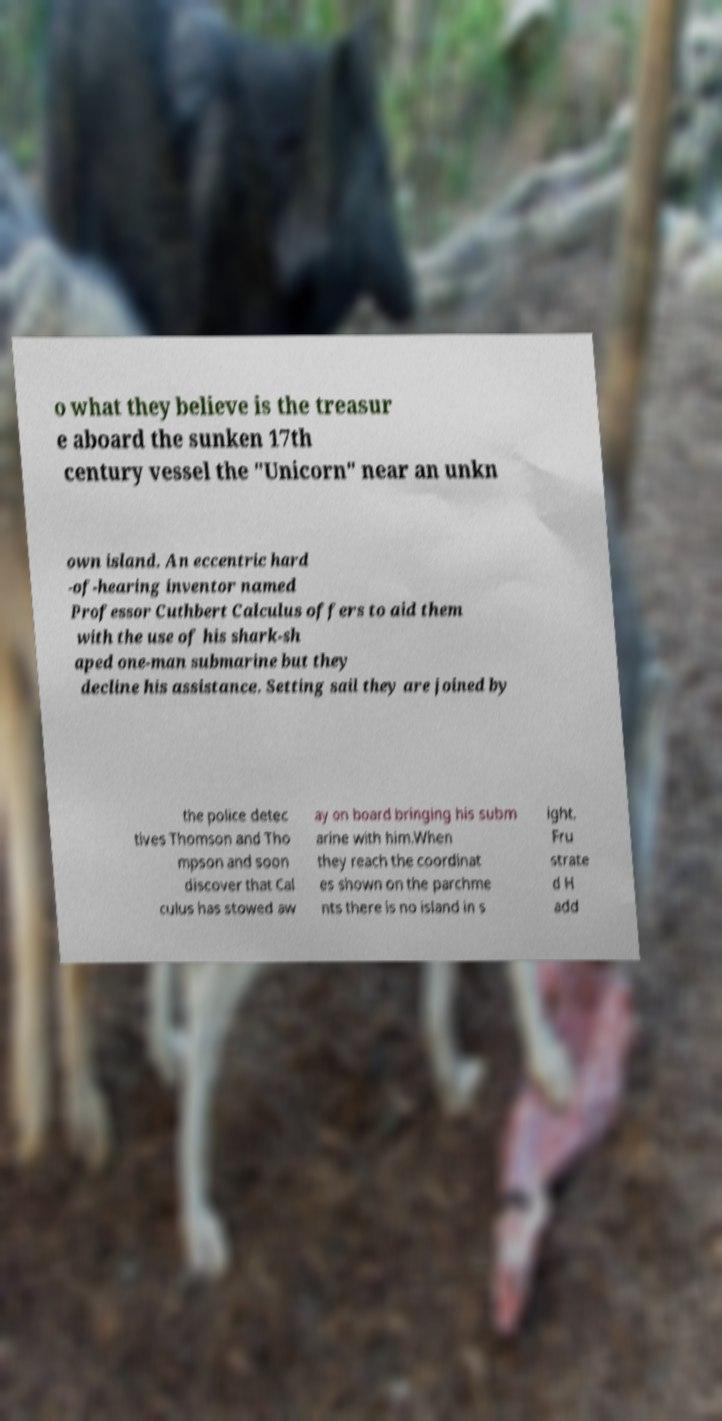Can you accurately transcribe the text from the provided image for me? o what they believe is the treasur e aboard the sunken 17th century vessel the "Unicorn" near an unkn own island. An eccentric hard -of-hearing inventor named Professor Cuthbert Calculus offers to aid them with the use of his shark-sh aped one-man submarine but they decline his assistance. Setting sail they are joined by the police detec tives Thomson and Tho mpson and soon discover that Cal culus has stowed aw ay on board bringing his subm arine with him.When they reach the coordinat es shown on the parchme nts there is no island in s ight. Fru strate d H add 